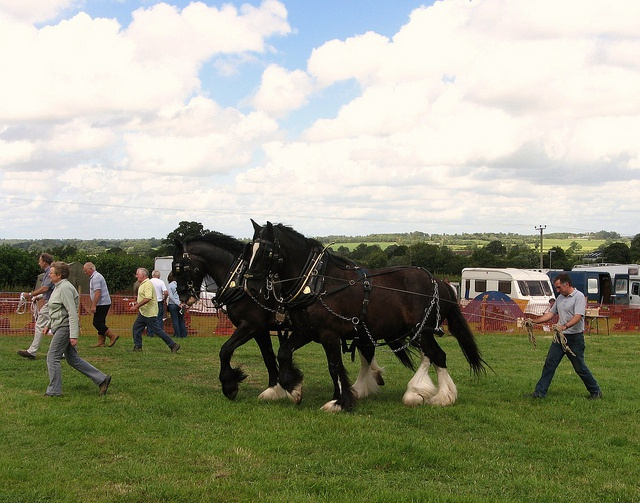Describe the objects in this image and their specific colors. I can see horse in white, black, gray, tan, and darkgreen tones, horse in white, black, gray, and darkgreen tones, people in white, black, darkgray, gray, and brown tones, people in white, gray, black, darkgray, and darkgreen tones, and car in white, lightgray, darkgray, and black tones in this image. 